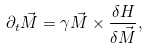<formula> <loc_0><loc_0><loc_500><loc_500>\partial _ { t } \vec { M } = \gamma \vec { M } \times \frac { \delta H } { \delta \vec { M } } ,</formula> 